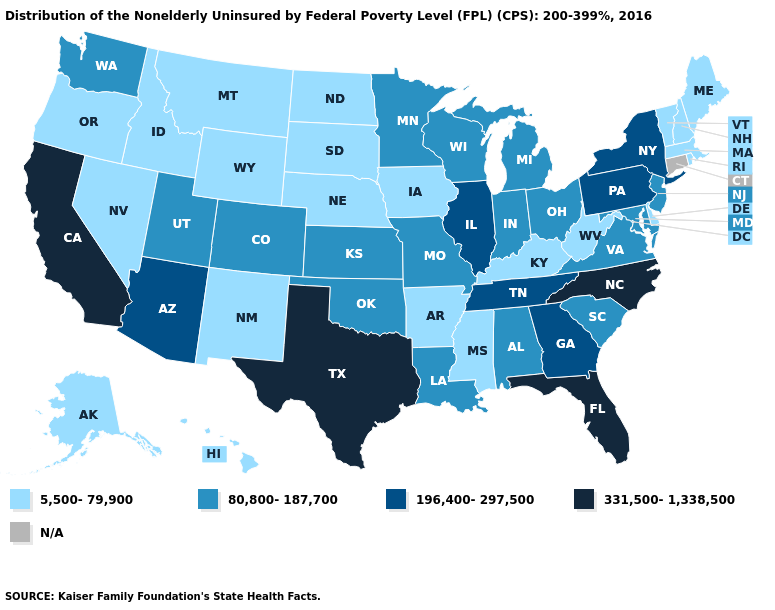Does the first symbol in the legend represent the smallest category?
Give a very brief answer. Yes. Which states have the lowest value in the South?
Answer briefly. Arkansas, Delaware, Kentucky, Mississippi, West Virginia. Among the states that border Colorado , does Kansas have the highest value?
Quick response, please. No. What is the value of Georgia?
Concise answer only. 196,400-297,500. Does Pennsylvania have the highest value in the Northeast?
Be succinct. Yes. Which states have the lowest value in the USA?
Quick response, please. Alaska, Arkansas, Delaware, Hawaii, Idaho, Iowa, Kentucky, Maine, Massachusetts, Mississippi, Montana, Nebraska, Nevada, New Hampshire, New Mexico, North Dakota, Oregon, Rhode Island, South Dakota, Vermont, West Virginia, Wyoming. What is the value of Minnesota?
Be succinct. 80,800-187,700. What is the value of Oklahoma?
Concise answer only. 80,800-187,700. Does Indiana have the lowest value in the USA?
Quick response, please. No. Does Mississippi have the highest value in the USA?
Keep it brief. No. Does the map have missing data?
Write a very short answer. Yes. Does West Virginia have the lowest value in the USA?
Short answer required. Yes. What is the highest value in the West ?
Short answer required. 331,500-1,338,500. 